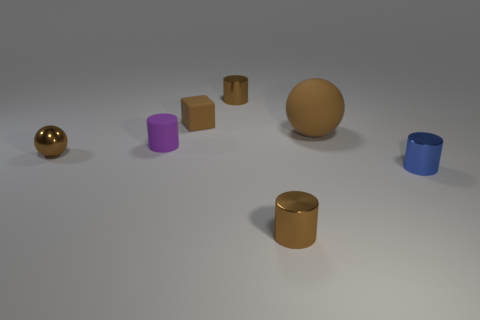There is a brown metallic cylinder that is in front of the brown rubber cube; is its size the same as the big object?
Give a very brief answer. No. The other matte object that is the same shape as the small blue object is what size?
Your response must be concise. Small. There is a blue thing that is the same size as the brown cube; what is it made of?
Your response must be concise. Metal. There is a purple object that is the same shape as the blue metal object; what is its material?
Make the answer very short. Rubber. What number of other things are the same size as the purple matte thing?
Provide a succinct answer. 5. There is a metallic sphere that is the same color as the big thing; what is its size?
Provide a succinct answer. Small. What number of balls are the same color as the large thing?
Your answer should be compact. 1. What shape is the large brown rubber thing?
Make the answer very short. Sphere. There is a thing that is in front of the purple rubber object and on the left side of the tiny brown matte cube; what is its color?
Offer a terse response. Brown. What material is the big brown thing?
Your answer should be compact. Rubber. 